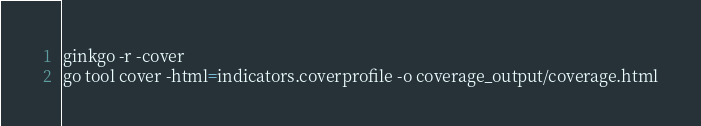<code> <loc_0><loc_0><loc_500><loc_500><_Bash_>ginkgo -r -cover
go tool cover -html=indicators.coverprofile -o coverage_output/coverage.html
</code> 